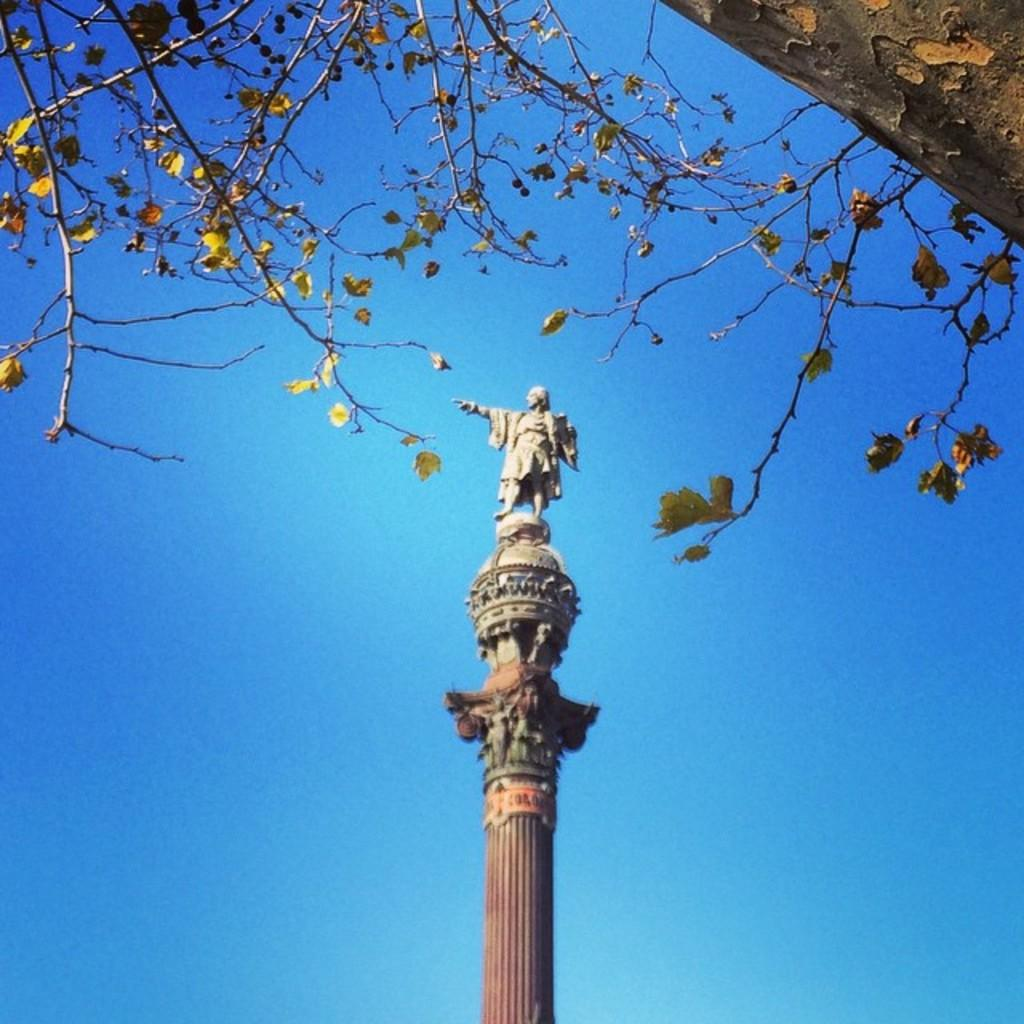What type of plant can be seen in the image? There is a tree in the image. What other object is present in the image besides the tree? There is a pillar with a sculpture in the image. What type of bread can be seen in the image? There is no bread present in the image; it only features a tree and a pillar with a sculpture. 